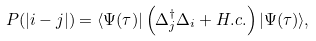<formula> <loc_0><loc_0><loc_500><loc_500>P ( | i - j | ) = \langle \Psi ( \tau ) | \left ( \Delta _ { j } ^ { \dagger } \Delta _ { i } + H . c . \right ) | \Psi ( \tau ) \rangle ,</formula> 